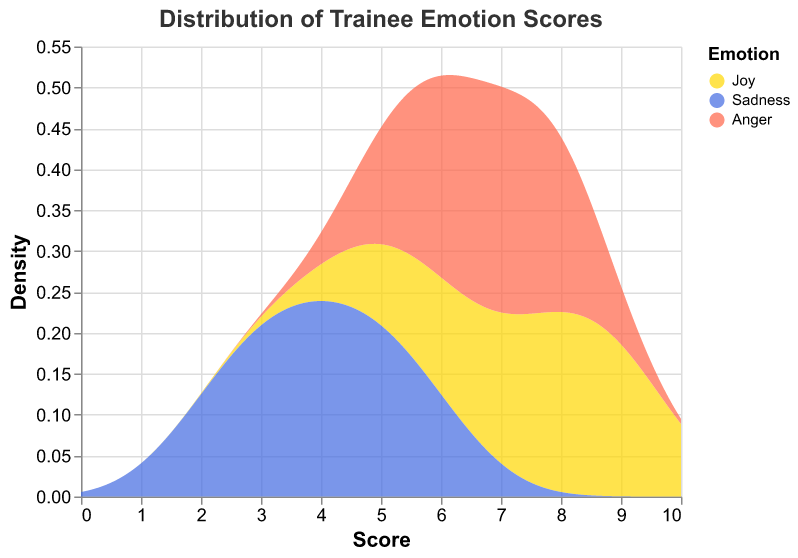What is the title of the figure? The title of the figure is at the top and states what the graph represents. It provides context to understand the visualized data.
Answer: Distribution of Trainee Emotion Scores What emotions are shown in the figure? The emotions are identified by different colors in the legend. The legend lists all the emotions included in the visualization.
Answer: Joy, Sadness, Anger Which emotion has the highest score on average? By examining the density curves, we look for the peak average score for each emotion. The closer the peak is to the higher end of the score axis, the higher the average.
Answer: Joy Which emotion shows the widest range of scores? The range of scores can be observed from the spread of the density curve along the x-axis. The emotion with the widest density curve represents the greatest range.
Answer: Joy Which score is the most common for anger? The peak of the density curve for anger indicates the most frequent score. The highest point on the anger density curve represents the mode.
Answer: 7 What is the score distribution trend for sadness? We analyze the density curve for sadness. The trend shows how scores are spread, indicating if they're more clustered around certain values or evenly spread.
Answer: Clustered around 3 to 5 How many scores are less than 6 for joy? Identify the proportion of the density curve for joy that lies to the left of the score 6. Counting the equivalent data points gives the answer.
Answer: None Which emotion displays the most variability in scores? Variability is indicated by the spread of the density curve. The emotion with the most spread curve shows the greatest variability in scores.
Answer: Joy How does the density of scores for 8 differ between joy and anger? Compare the height of the density curves for joy and anger at score 8. Higher density means more frequent occurrences of that score.
Answer: Joy's density is higher 